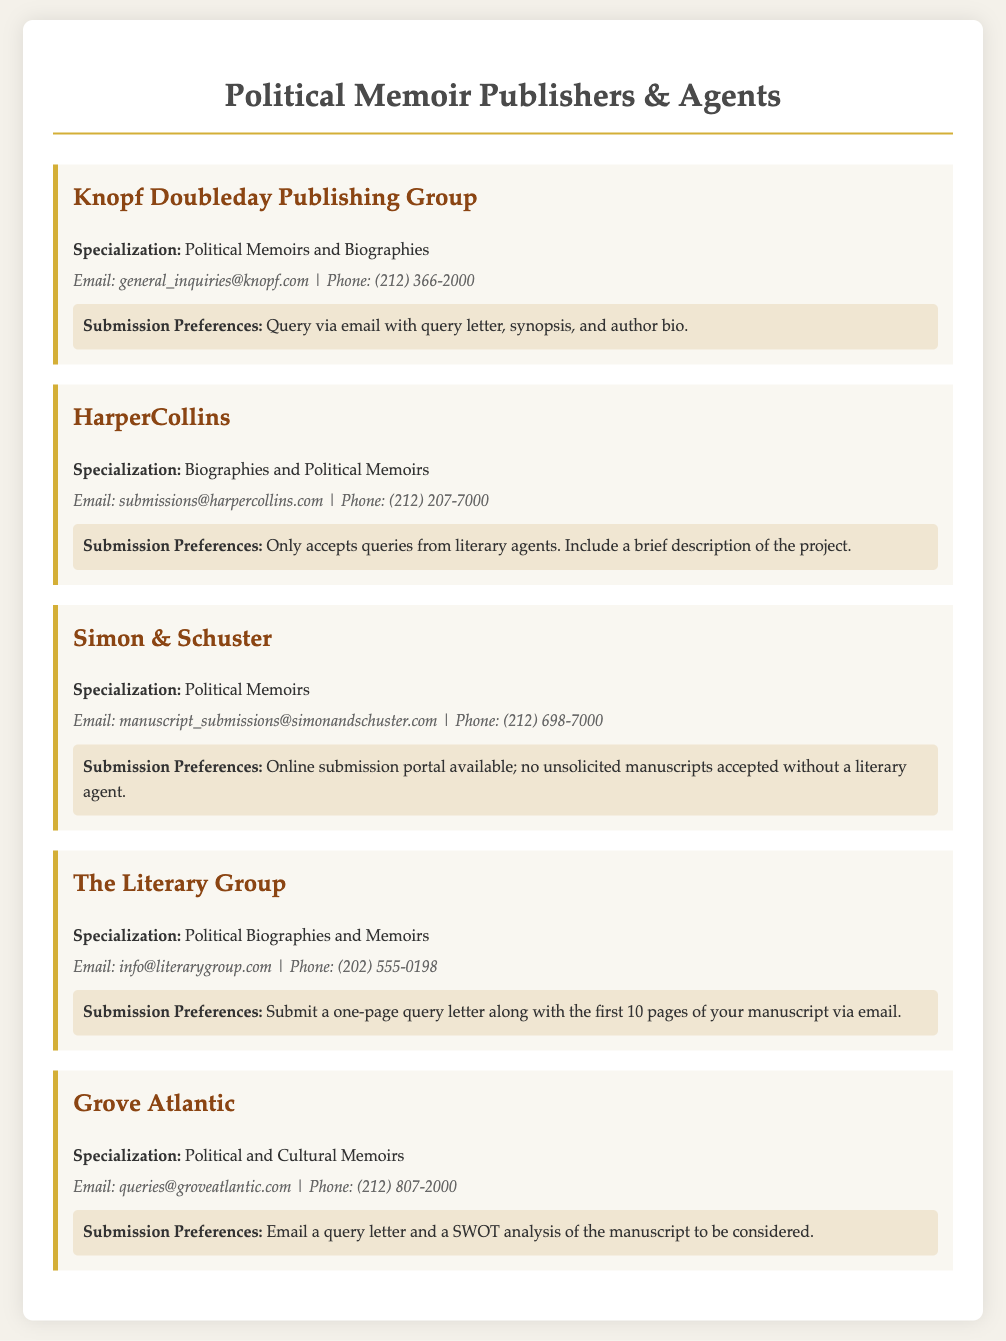What is the email contact for Knopf Doubleday Publishing Group? The email contact is specified in the document under the publisher's section for Knopf Doubleday Publishing Group.
Answer: general_inquiries@knopf.com What is the submission preference for HarperCollins? The submission preference is mentioned in the document under the HarperCollins publisher section.
Answer: Only accepts queries from literary agents How many publishers are listed in the document? The number of publishers can be counted from the sections presented in the document.
Answer: 5 Which publisher specializes in cultural memoirs? The specialization is stated under the listed publishers, specifically where Grove Atlantic is mentioned.
Answer: Grove Atlantic What is the phone number for Simon & Schuster? The phone number is provided in the contact information for Simon & Schuster in the document.
Answer: (212) 698-7000 What type of memoirs does The Literary Group focus on? The focus of The Literary Group is indicated in the specialization section of the document.
Answer: Political Biographies and Memoirs What is required to submit to Grove Atlantic? The requirements are detailed under the submission preferences of Grove Atlantic.
Answer: Email a query letter and a SWOT analysis Which publisher does not accept unsolicited manuscripts? The document explicitly states submission preferences for Simon & Schuster, indicating this practice.
Answer: Simon & Schuster 